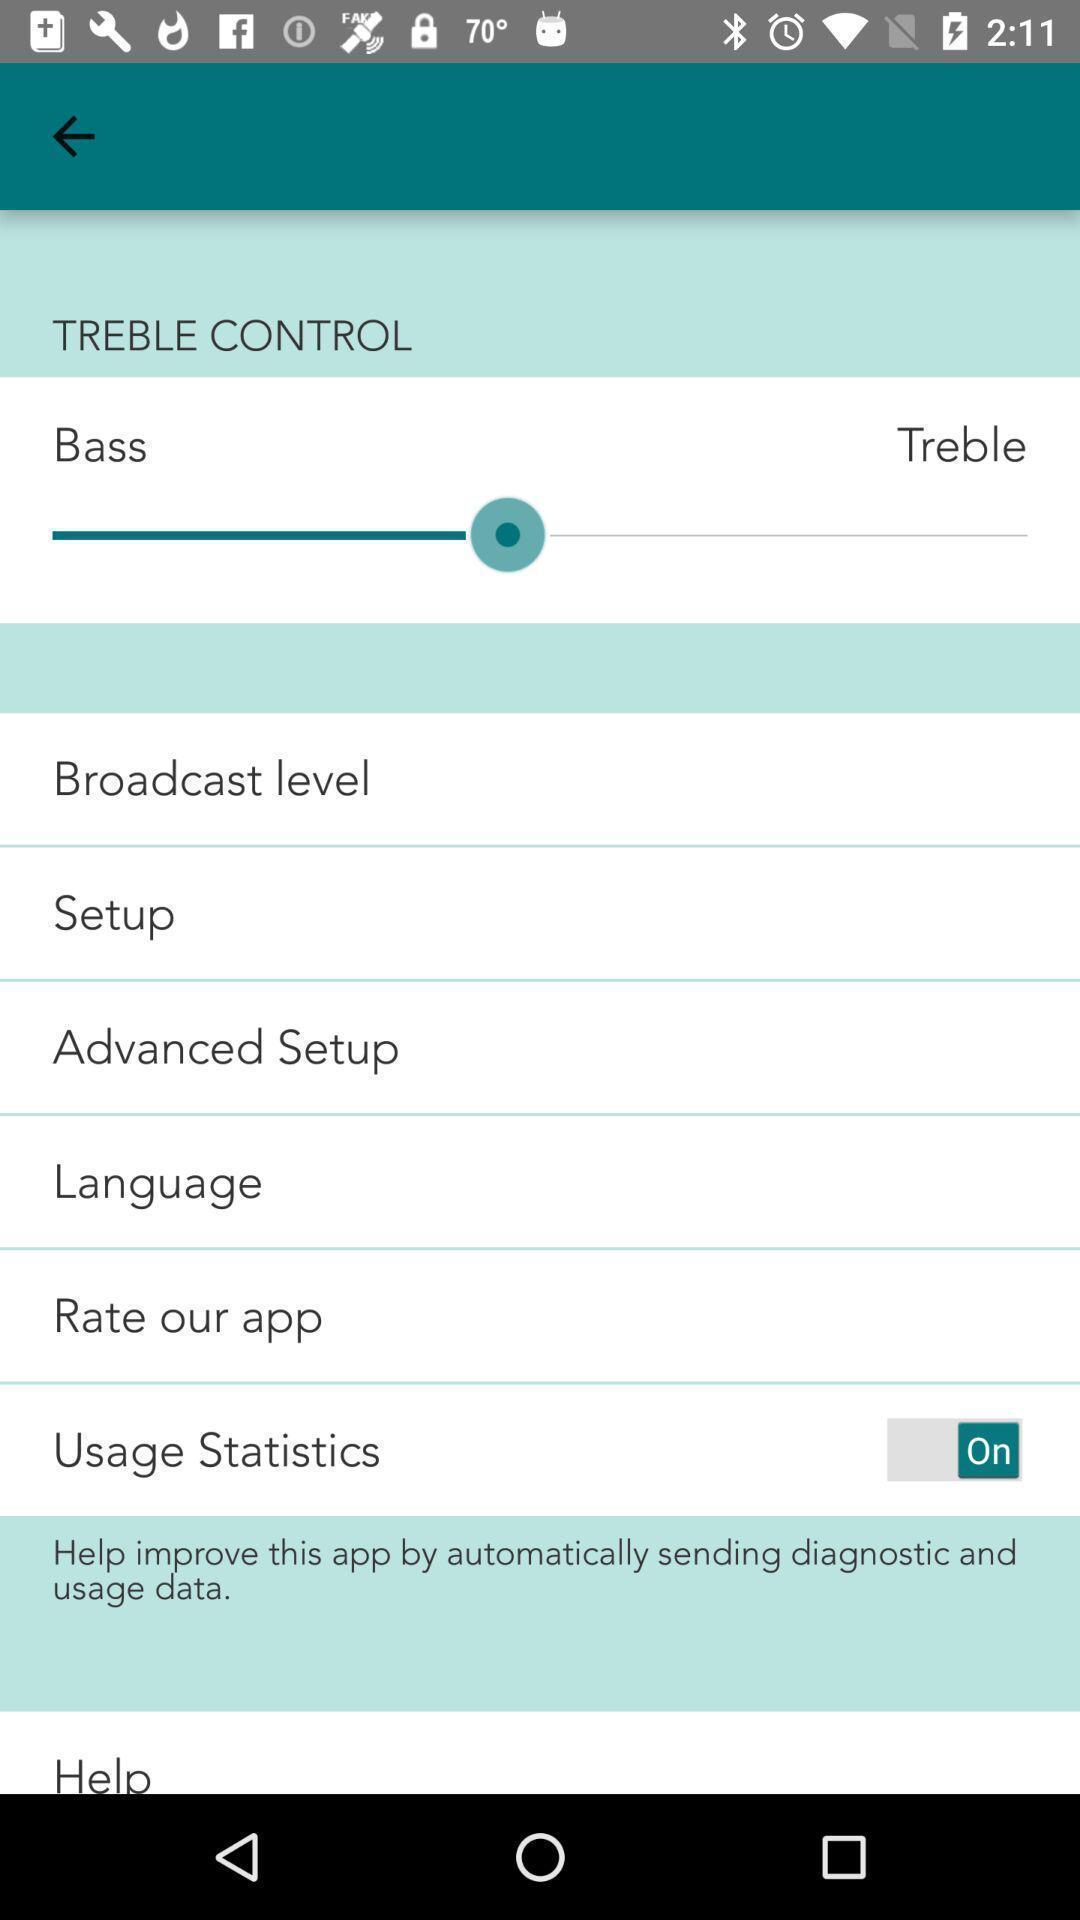What details can you identify in this image? Page displaying with list of different aspects. 